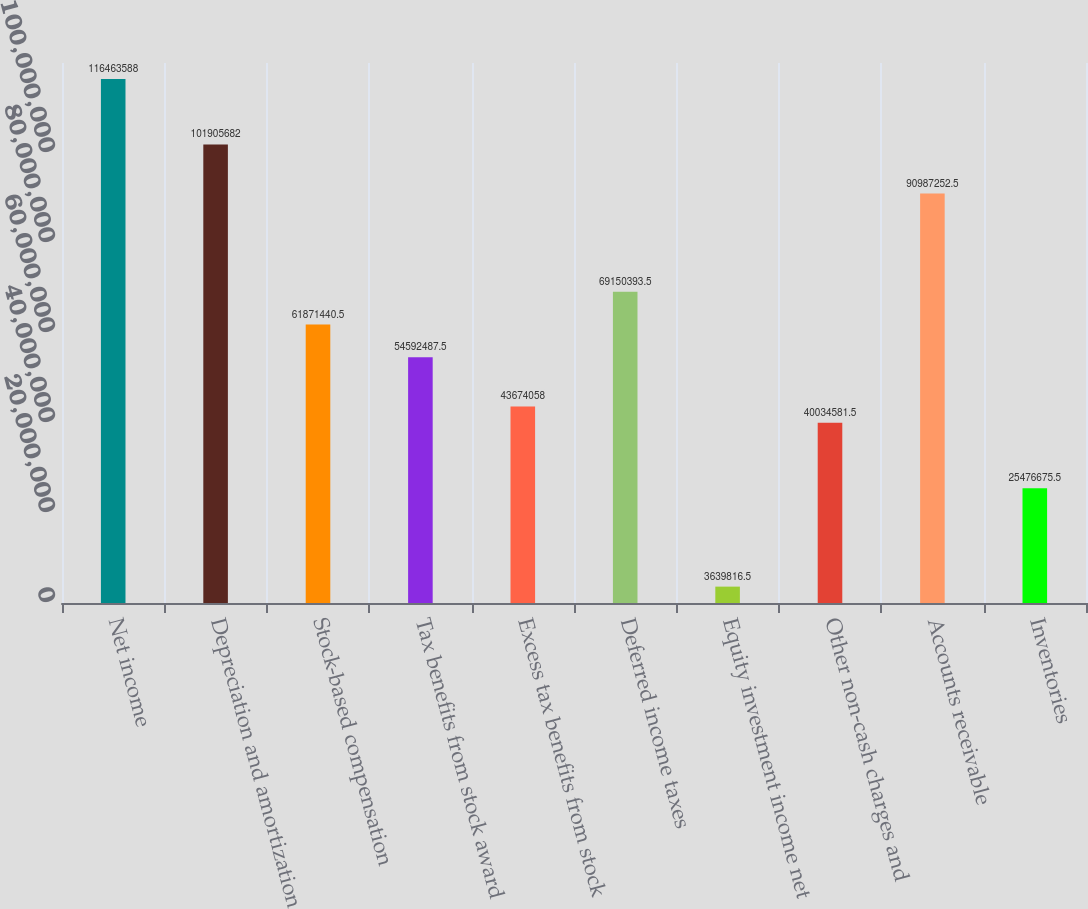<chart> <loc_0><loc_0><loc_500><loc_500><bar_chart><fcel>Net income<fcel>Depreciation and amortization<fcel>Stock-based compensation<fcel>Tax benefits from stock award<fcel>Excess tax benefits from stock<fcel>Deferred income taxes<fcel>Equity investment income net<fcel>Other non-cash charges and<fcel>Accounts receivable<fcel>Inventories<nl><fcel>1.16464e+08<fcel>1.01906e+08<fcel>6.18714e+07<fcel>5.45925e+07<fcel>4.36741e+07<fcel>6.91504e+07<fcel>3.63982e+06<fcel>4.00346e+07<fcel>9.09873e+07<fcel>2.54767e+07<nl></chart> 